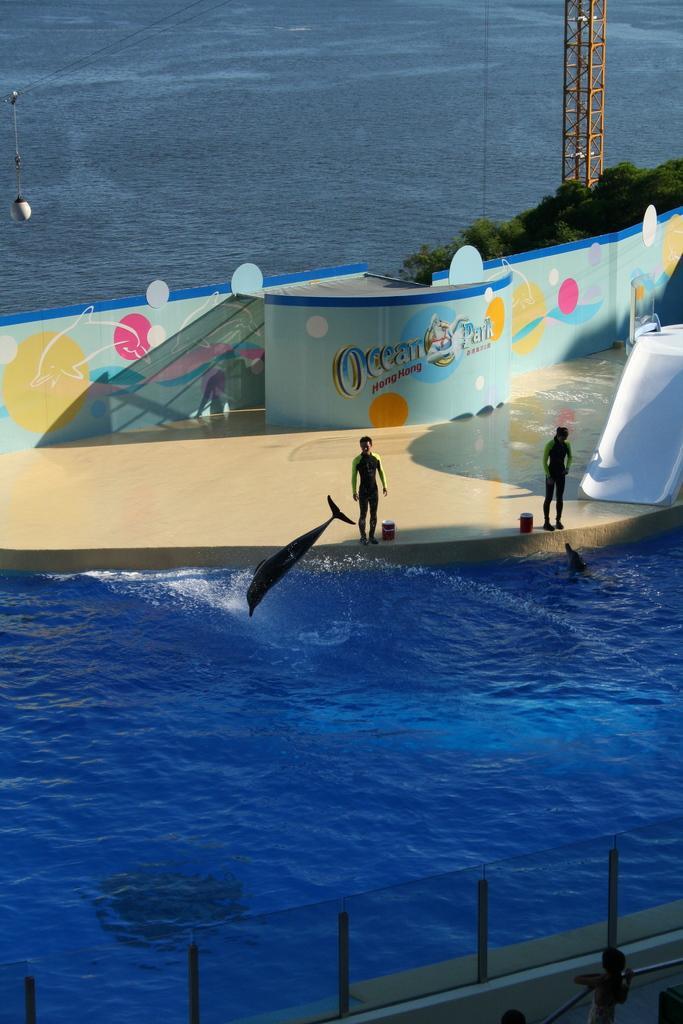In one or two sentences, can you explain what this image depicts? In this image we can see water, dolphins and persons standing. In the background we can see a wall, trees and pole. 